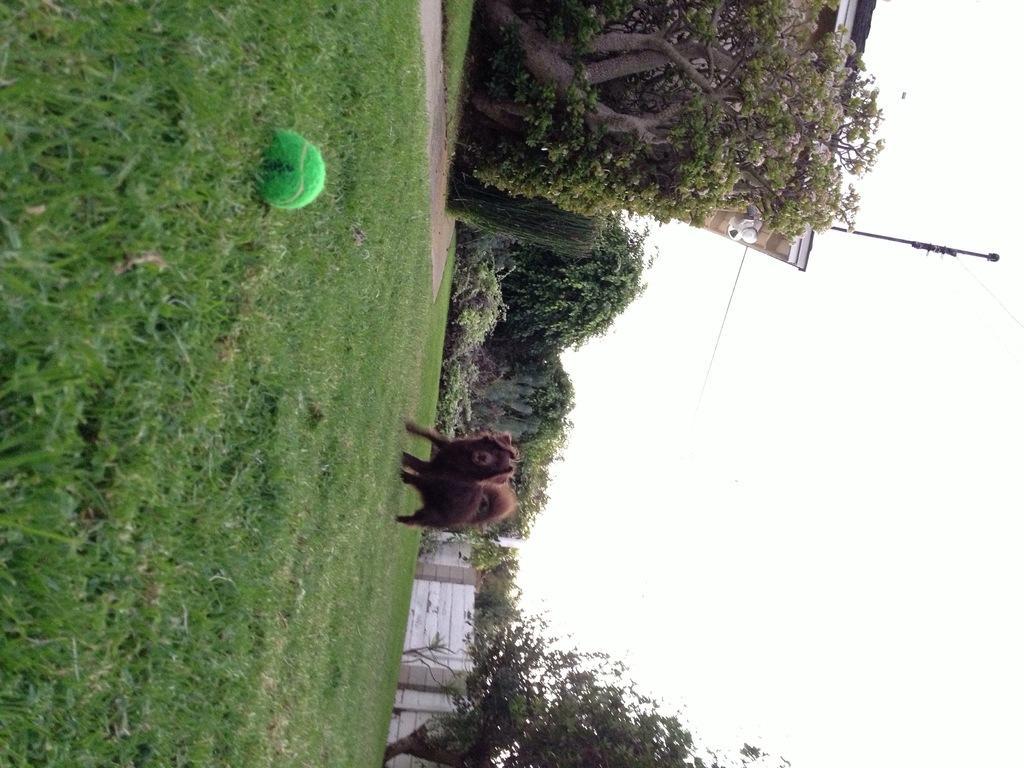Please provide a concise description of this image. In this image I can see an open grass ground in the centre and on it I can see a brown colour dog and a green colour ball. In the background I can see number of trees, a building and on the top of the building I can see a pole. 